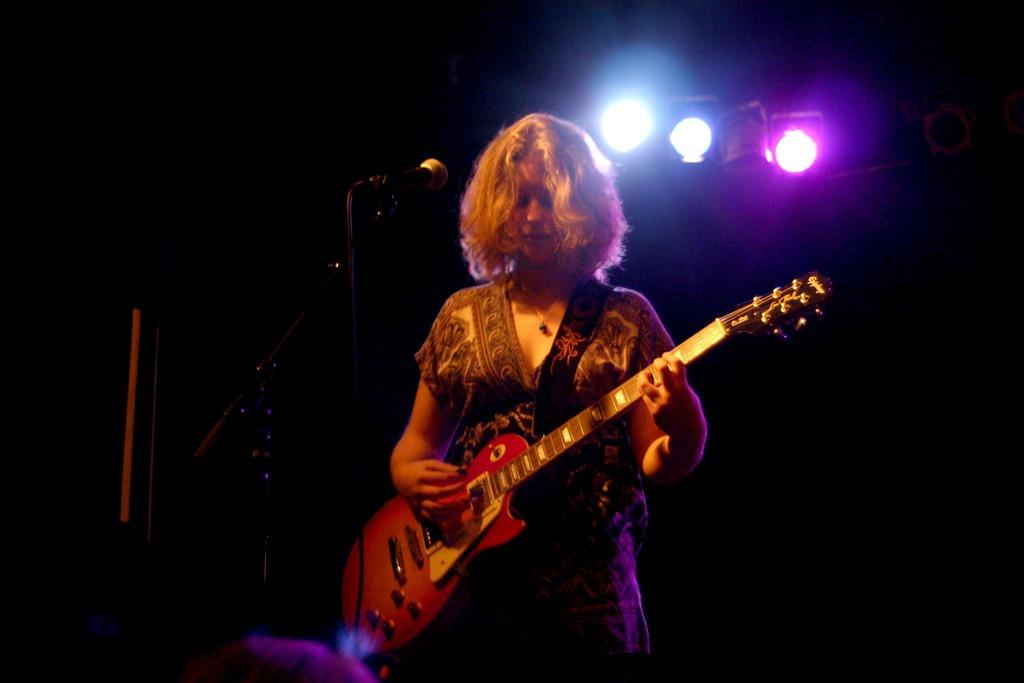Who is the main subject in the image? There is a lady in the image. What is the lady doing in the image? The lady is standing and playing a guitar. What object is in front of the lady? There is a microphone in front of the lady. How many lights can be seen in the image? There are three lights visible in the image. What direction is the secretary facing with the rifle in the image? There is no secretary or rifle present in the image. 